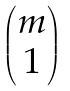<formula> <loc_0><loc_0><loc_500><loc_500>\begin{pmatrix} m \\ 1 \end{pmatrix}</formula> 